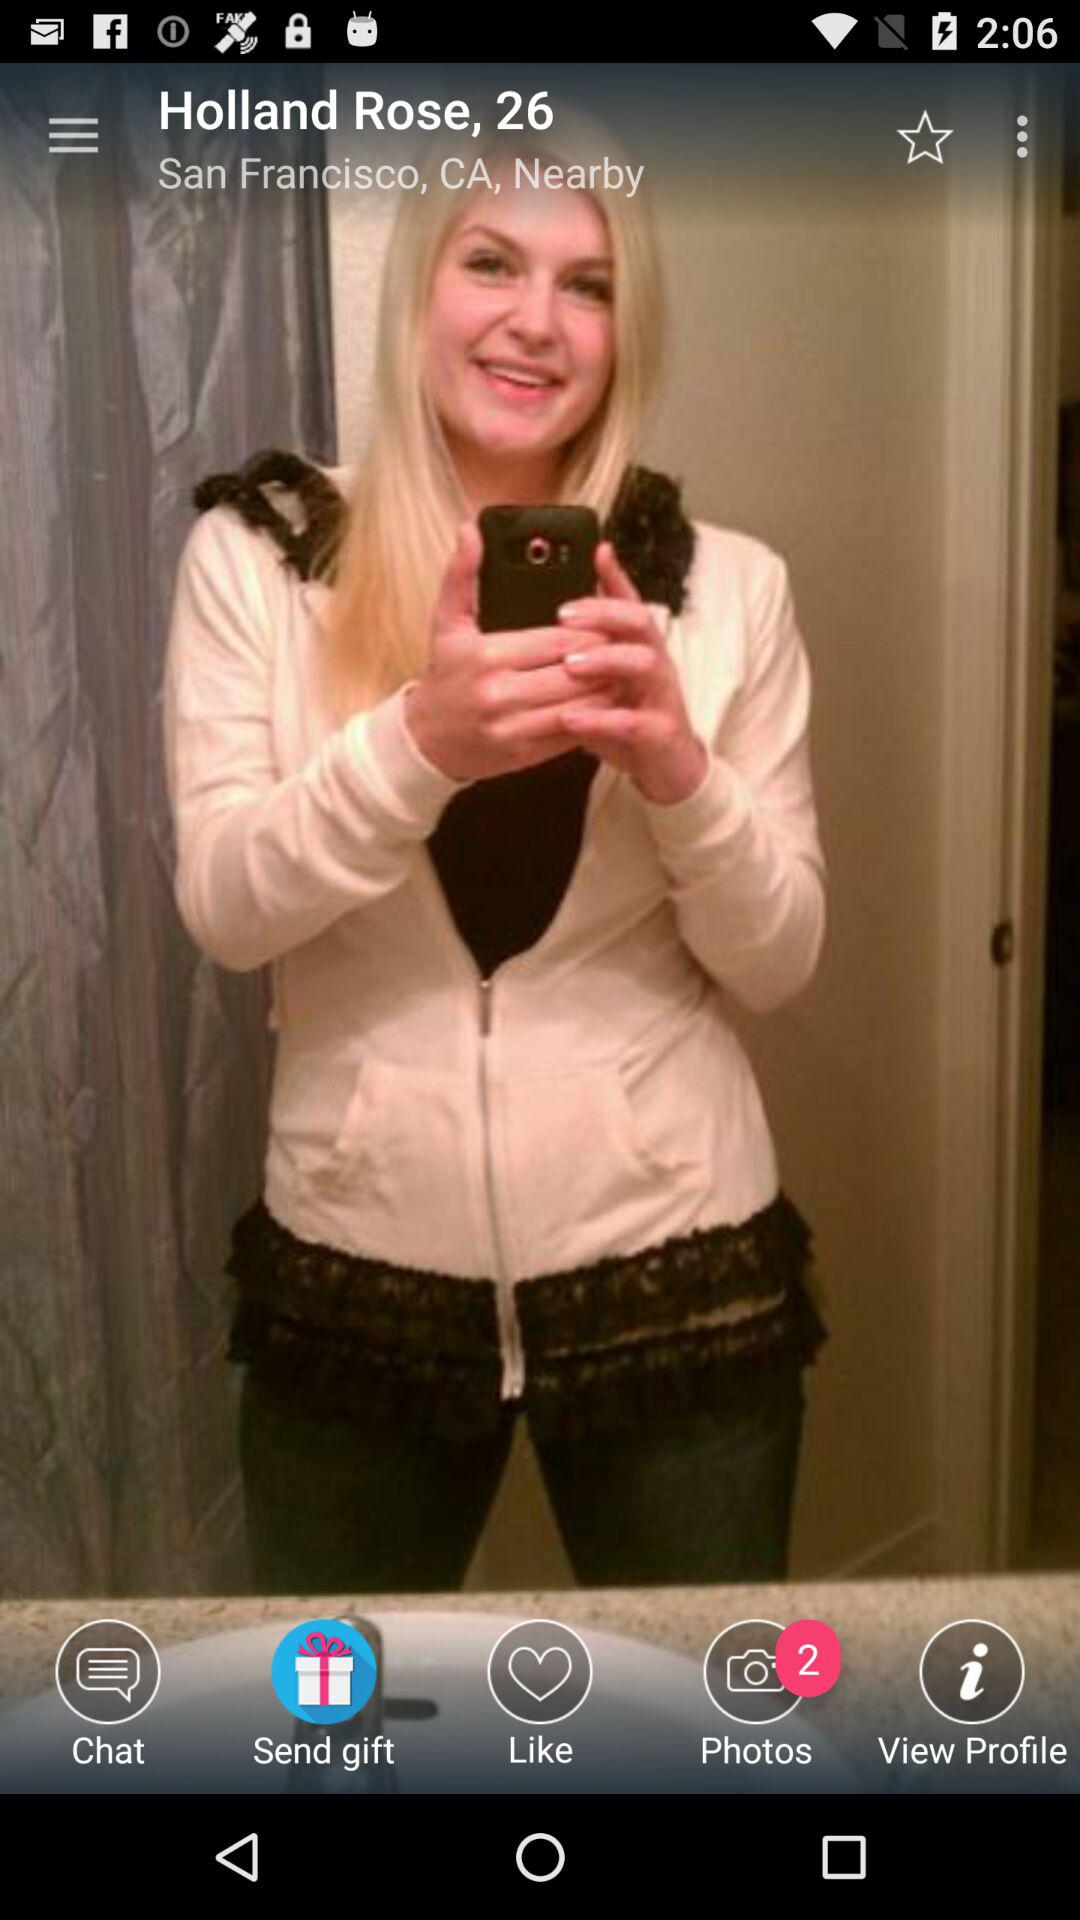What is the location? The location is San Francisco, CA. 